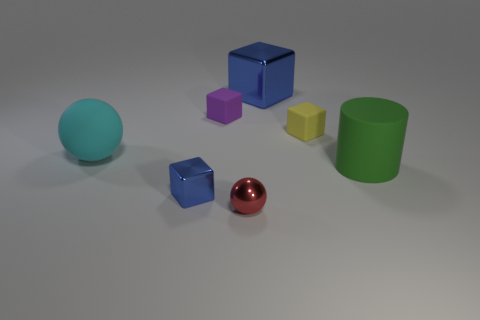Are there any other things that have the same shape as the green object?
Offer a terse response. No. Does the block that is in front of the large green rubber cylinder have the same color as the block behind the tiny purple cube?
Your response must be concise. Yes. The large thing that is both right of the cyan rubber thing and behind the large rubber cylinder has what shape?
Your answer should be compact. Cube. There is a metal cube that is the same size as the purple rubber thing; what is its color?
Your answer should be compact. Blue. Are there any big shiny objects that have the same color as the small shiny block?
Ensure brevity in your answer.  Yes. Does the sphere that is on the right side of the big matte ball have the same size as the blue thing that is behind the yellow cube?
Provide a succinct answer. No. What material is the big object that is on the left side of the yellow rubber block and right of the red metallic sphere?
Offer a terse response. Metal. There is a object that is the same color as the small metallic block; what size is it?
Ensure brevity in your answer.  Large. How many other objects are the same size as the red shiny ball?
Your response must be concise. 3. There is a blue object that is to the right of the tiny shiny block; what is it made of?
Provide a succinct answer. Metal. 